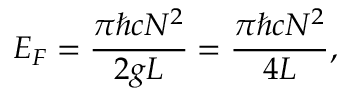Convert formula to latex. <formula><loc_0><loc_0><loc_500><loc_500>E _ { F } = \frac { \pi \hbar { c } N ^ { 2 } } { 2 g L } = \frac { \pi \hbar { c } N ^ { 2 } } { 4 L } ,</formula> 